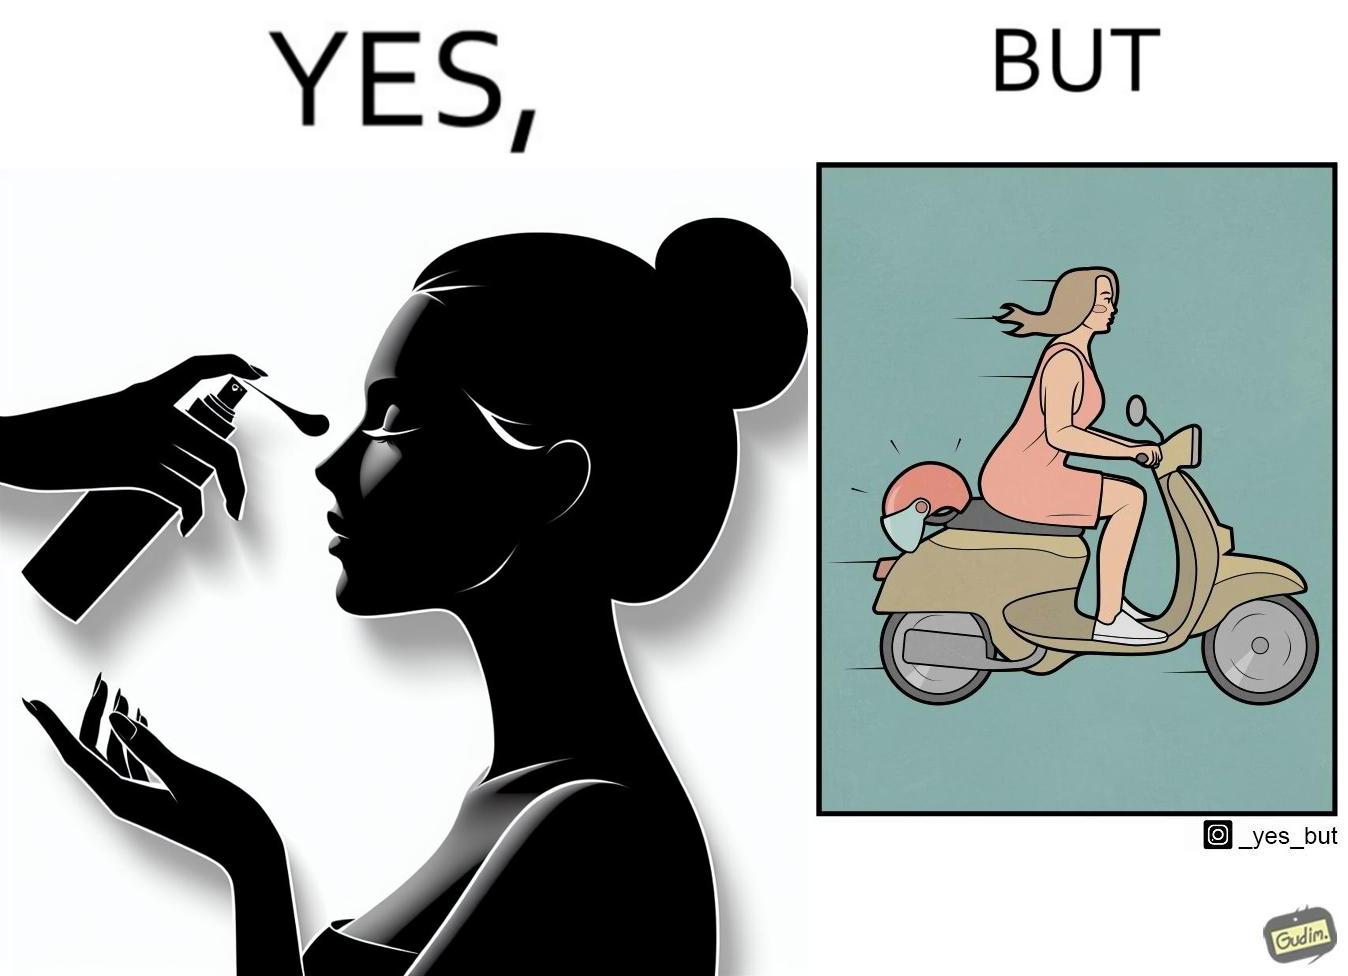Describe what you see in this image. The image is funny because while the woman is concerned about protection from the sun rays, she is not concerned about her safety while riding a scooter. 